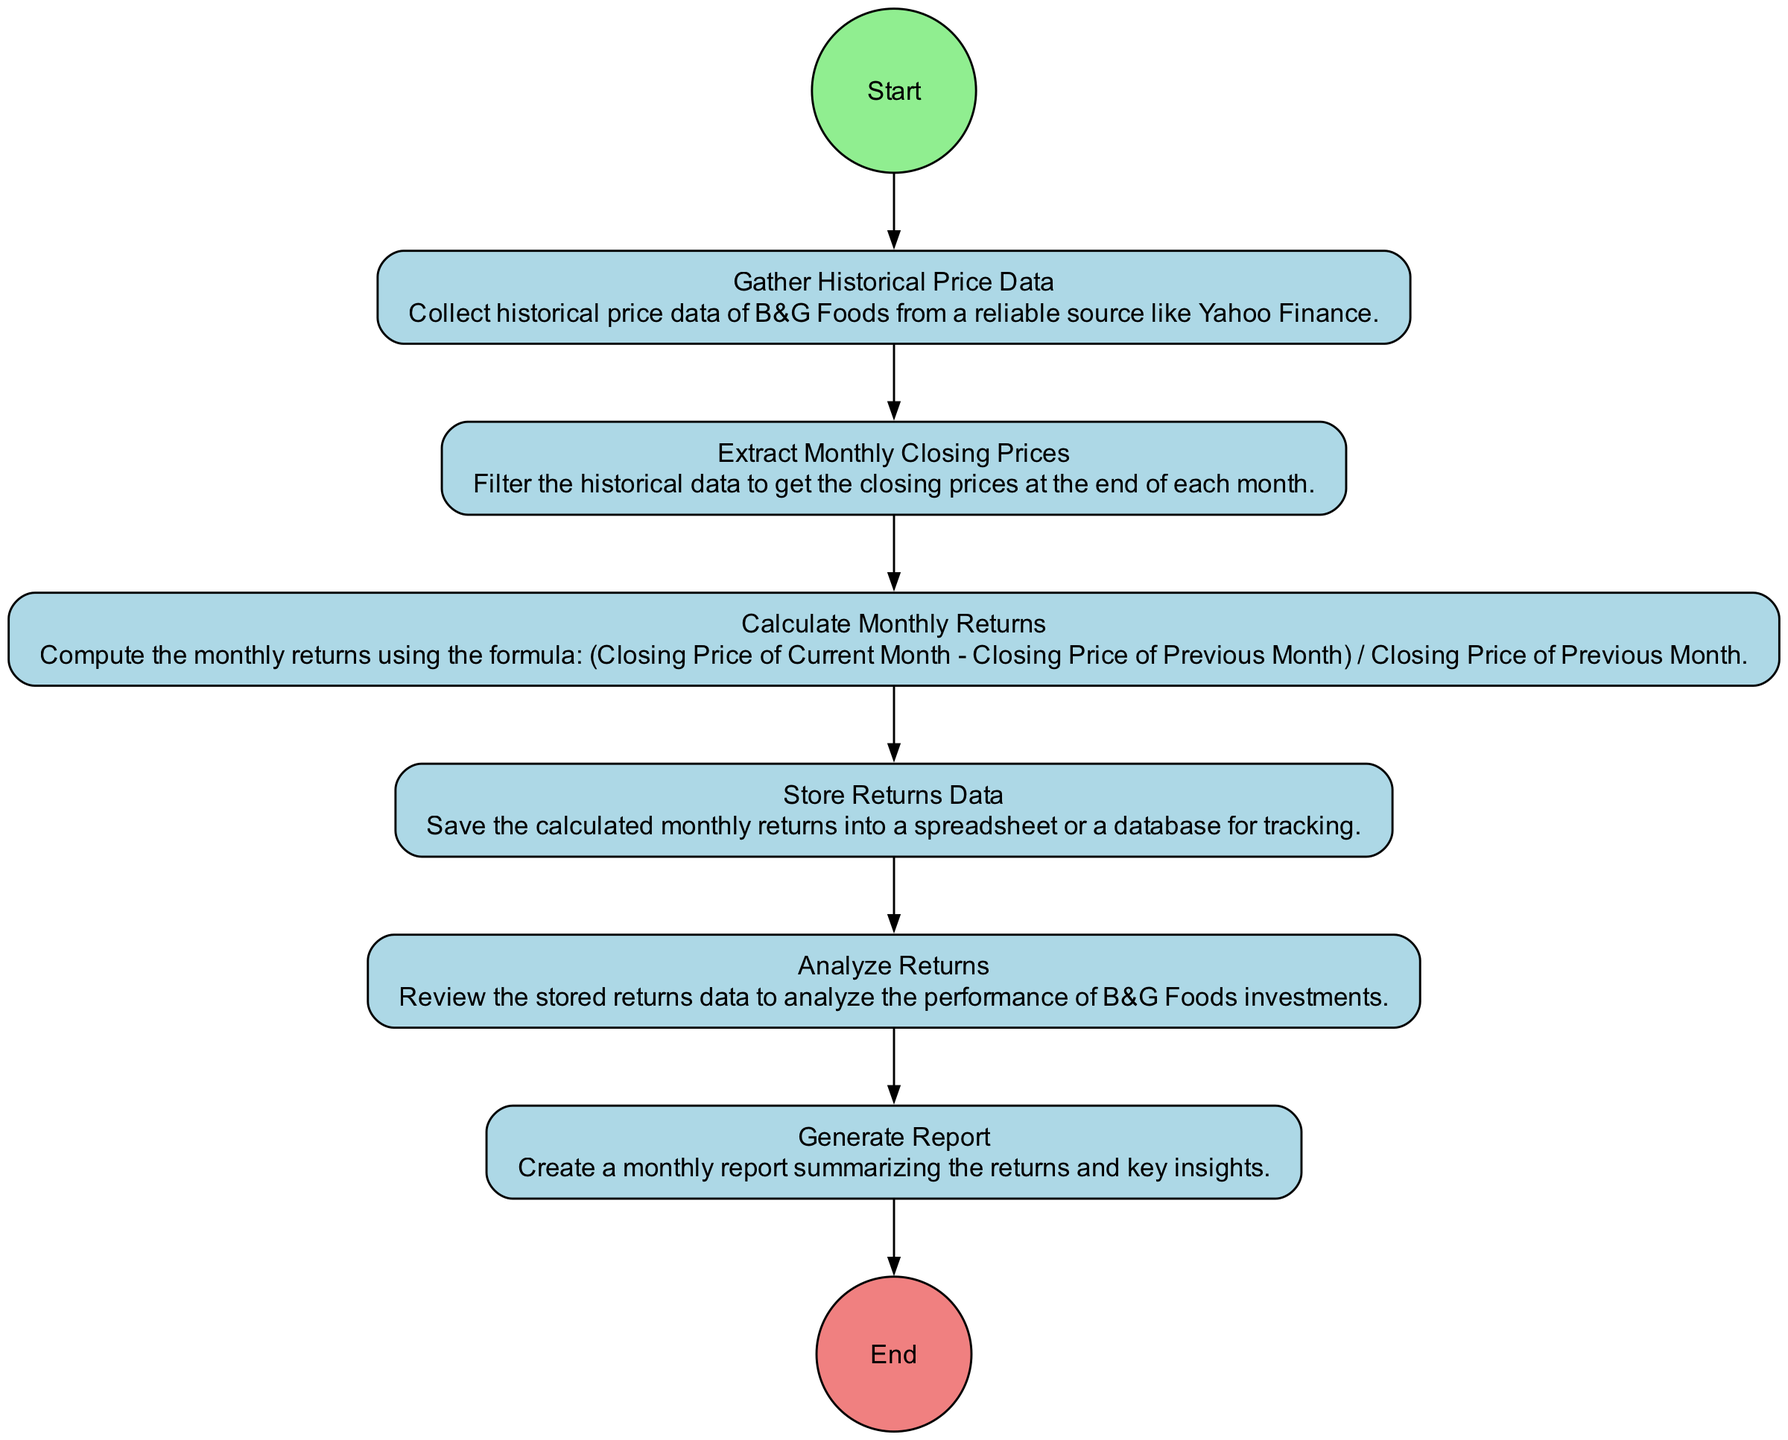What is the first activity in the workflow? The first activity in the workflow is represented by the node that starts the process. In the diagram, this is labeled "Start," indicating the beginning of the entire workflow.
Answer: Start How many actions are there in total? By reviewing the diagram, I count the actions, which are all activities that are not marked as start or end. The actions include Gathering Historical Price Data, Extract Monthly Closing Prices, Calculate Monthly Returns, Store Returns Data, Analyze Returns, and Generate Report. Hence, there are six actions.
Answer: Six Which activity comes after "Calculate Monthly Returns"? The transition from the "Calculate Monthly Returns" node leads directly to the next activity, which is "Store Returns Data." This means that "Store Returns Data" is the subsequent step in the workflow.
Answer: Store Returns Data What activity is the last one before the end? The last action before reaching the end of the workflow can be determined by looking at the final transition leading to the "End" node. This transition shows that "Generate Report" is the last activity before the workflow concludes.
Answer: Generate Report How many edges connect the activities? To obtain the total number of edges, I observe the number of transitions between activities in the workflow. Each transition is represented as an edge connecting two activities. Counting these, there are seven edges.
Answer: Seven What is the purpose of the "Analyze Returns" activity? By looking at the description of the "Analyze Returns" activity listed in the diagram, its purpose is to review the stored returns data, aiding in understanding the performance of B&G Foods investments.
Answer: Review performance What type of diagram is this? This diagram is an Activity Diagram, which is specifically designed to show the workflow of processes and the sequence of activities involved.
Answer: Activity Diagram Which activity directly follows "Extract Monthly Closing Prices"? Following the "Extract Monthly Closing Prices" in the workflow sequence, the next activity is "Calculate Monthly Returns," as indicated by the transition after this action.
Answer: Calculate Monthly Returns 